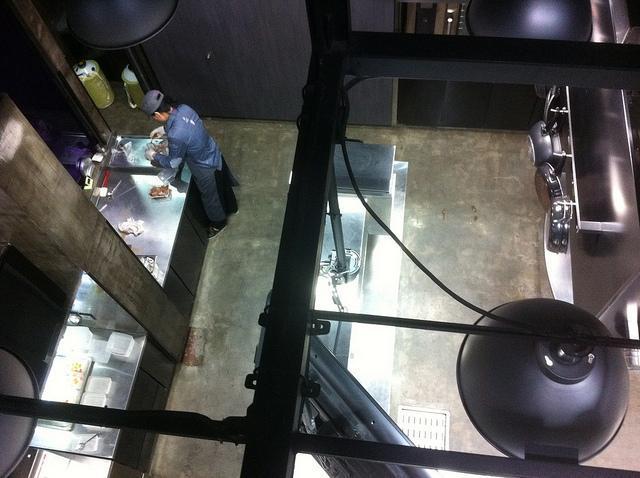How many windows on this airplane are touched by red or orange paint?
Give a very brief answer. 0. 